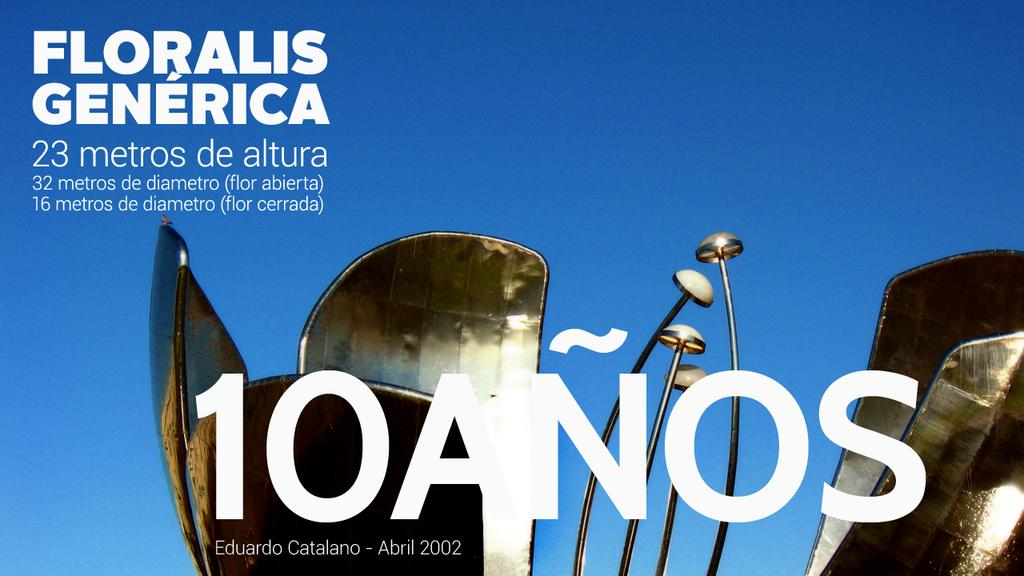<image>
Render a clear and concise summary of the photo. the top of a metal sculpture against the blue sky and a statement across it saying 10 anos. 